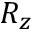Convert formula to latex. <formula><loc_0><loc_0><loc_500><loc_500>R _ { z }</formula> 